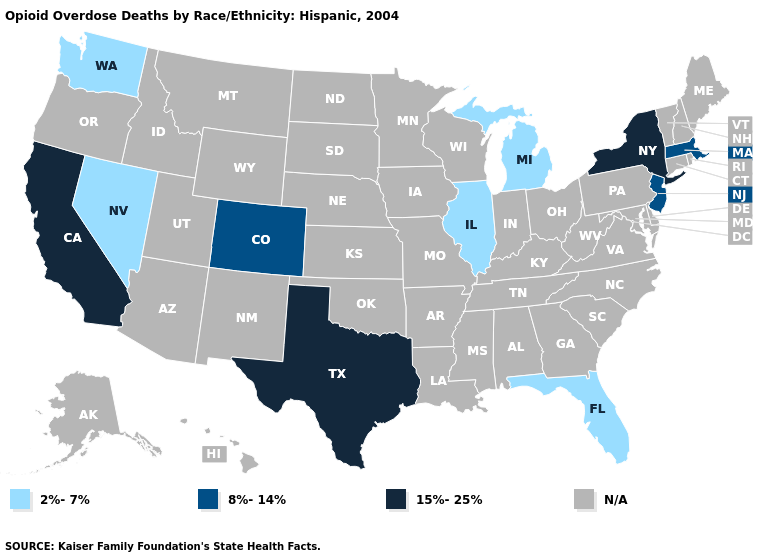What is the value of Iowa?
Answer briefly. N/A. What is the lowest value in states that border Utah?
Short answer required. 2%-7%. What is the highest value in the West ?
Be succinct. 15%-25%. What is the value of Massachusetts?
Quick response, please. 8%-14%. What is the value of Oklahoma?
Answer briefly. N/A. Which states hav the highest value in the South?
Be succinct. Texas. What is the highest value in the USA?
Give a very brief answer. 15%-25%. What is the lowest value in states that border Indiana?
Answer briefly. 2%-7%. What is the lowest value in the MidWest?
Short answer required. 2%-7%. Which states have the lowest value in the South?
Give a very brief answer. Florida. Does Texas have the lowest value in the South?
Give a very brief answer. No. Which states have the lowest value in the South?
Keep it brief. Florida. What is the value of Vermont?
Keep it brief. N/A. What is the value of Delaware?
Give a very brief answer. N/A. 